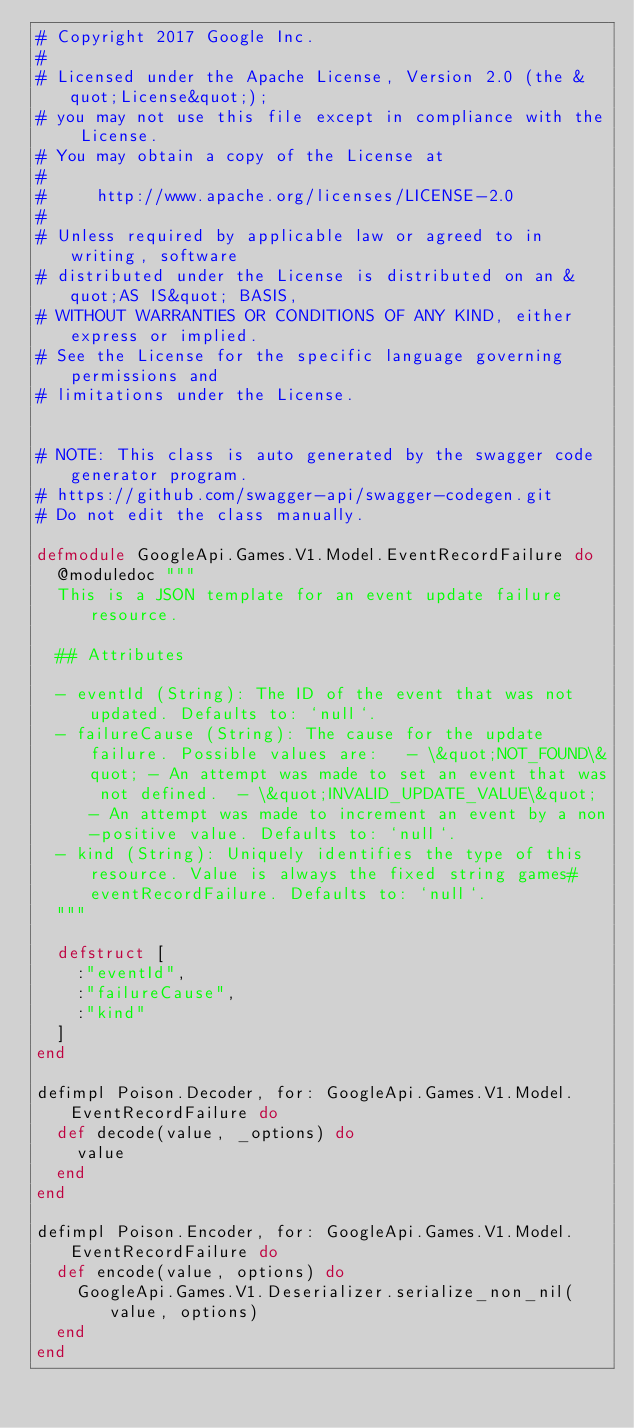<code> <loc_0><loc_0><loc_500><loc_500><_Elixir_># Copyright 2017 Google Inc.
#
# Licensed under the Apache License, Version 2.0 (the &quot;License&quot;);
# you may not use this file except in compliance with the License.
# You may obtain a copy of the License at
#
#     http://www.apache.org/licenses/LICENSE-2.0
#
# Unless required by applicable law or agreed to in writing, software
# distributed under the License is distributed on an &quot;AS IS&quot; BASIS,
# WITHOUT WARRANTIES OR CONDITIONS OF ANY KIND, either express or implied.
# See the License for the specific language governing permissions and
# limitations under the License.


# NOTE: This class is auto generated by the swagger code generator program.
# https://github.com/swagger-api/swagger-codegen.git
# Do not edit the class manually.

defmodule GoogleApi.Games.V1.Model.EventRecordFailure do
  @moduledoc """
  This is a JSON template for an event update failure resource.

  ## Attributes

  - eventId (String): The ID of the event that was not updated. Defaults to: `null`.
  - failureCause (String): The cause for the update failure. Possible values are:   - \&quot;NOT_FOUND\&quot; - An attempt was made to set an event that was not defined.  - \&quot;INVALID_UPDATE_VALUE\&quot; - An attempt was made to increment an event by a non-positive value. Defaults to: `null`.
  - kind (String): Uniquely identifies the type of this resource. Value is always the fixed string games#eventRecordFailure. Defaults to: `null`.
  """

  defstruct [
    :"eventId",
    :"failureCause",
    :"kind"
  ]
end

defimpl Poison.Decoder, for: GoogleApi.Games.V1.Model.EventRecordFailure do
  def decode(value, _options) do
    value
  end
end

defimpl Poison.Encoder, for: GoogleApi.Games.V1.Model.EventRecordFailure do
  def encode(value, options) do
    GoogleApi.Games.V1.Deserializer.serialize_non_nil(value, options)
  end
end

</code> 